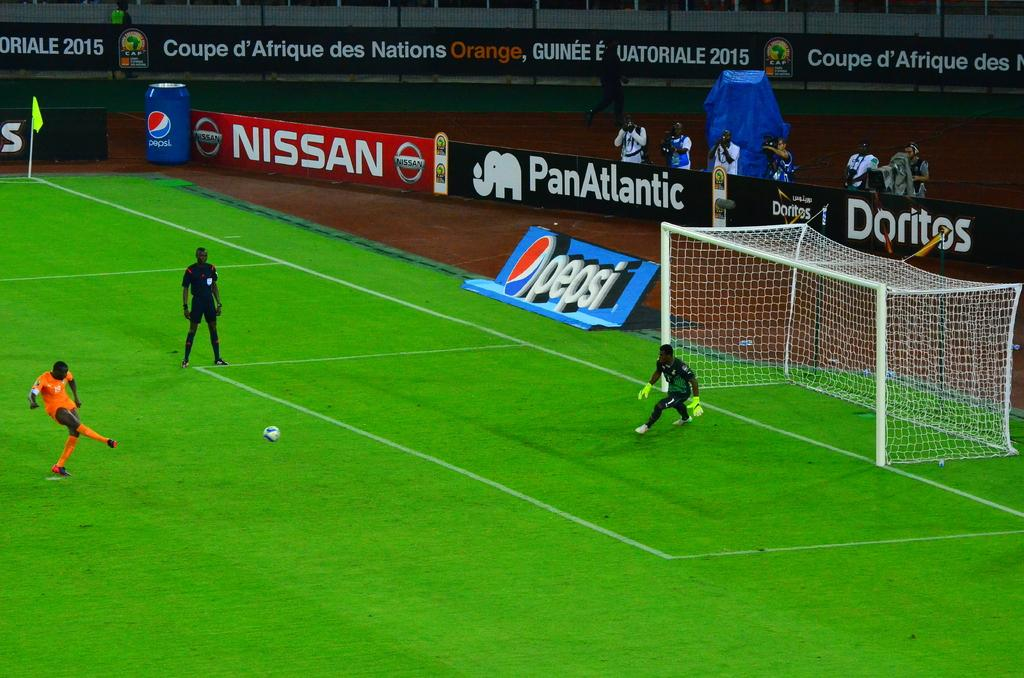<image>
Give a short and clear explanation of the subsequent image. Players playing soccer on a field with an advertisement for doritos behind them. 